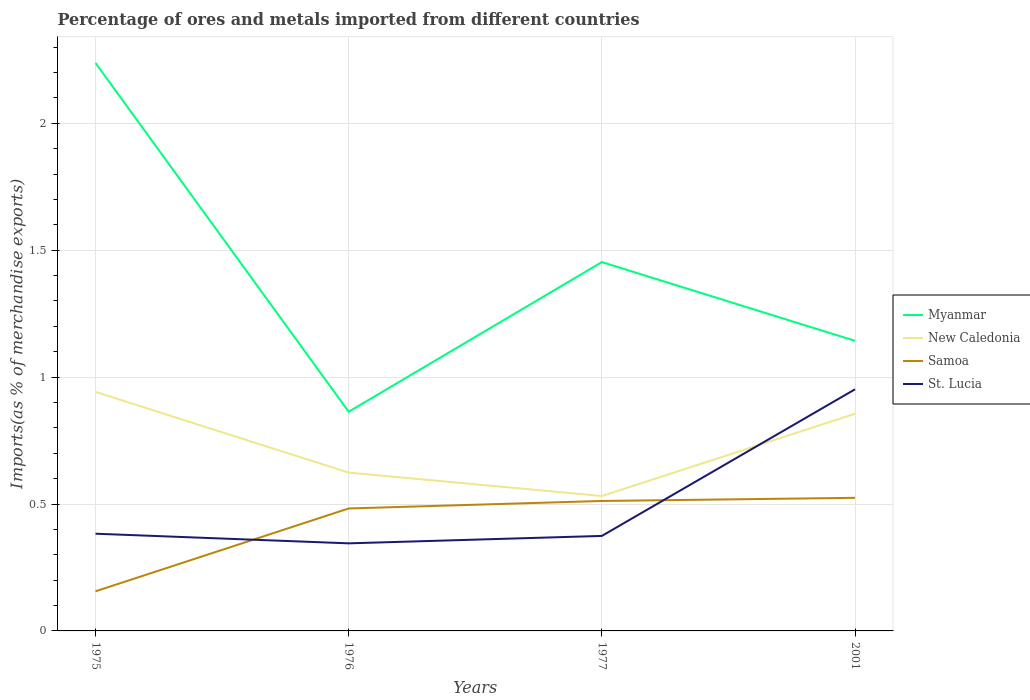Is the number of lines equal to the number of legend labels?
Offer a very short reply. Yes. Across all years, what is the maximum percentage of imports to different countries in New Caledonia?
Ensure brevity in your answer.  0.53. In which year was the percentage of imports to different countries in Samoa maximum?
Give a very brief answer. 1975. What is the total percentage of imports to different countries in Myanmar in the graph?
Your answer should be very brief. 0.78. What is the difference between the highest and the second highest percentage of imports to different countries in Myanmar?
Keep it short and to the point. 1.37. Is the percentage of imports to different countries in New Caledonia strictly greater than the percentage of imports to different countries in Myanmar over the years?
Ensure brevity in your answer.  Yes. Does the graph contain grids?
Give a very brief answer. Yes. Where does the legend appear in the graph?
Offer a very short reply. Center right. How many legend labels are there?
Ensure brevity in your answer.  4. What is the title of the graph?
Your response must be concise. Percentage of ores and metals imported from different countries. Does "Namibia" appear as one of the legend labels in the graph?
Keep it short and to the point. No. What is the label or title of the Y-axis?
Provide a short and direct response. Imports(as % of merchandise exports). What is the Imports(as % of merchandise exports) in Myanmar in 1975?
Offer a terse response. 2.24. What is the Imports(as % of merchandise exports) of New Caledonia in 1975?
Ensure brevity in your answer.  0.94. What is the Imports(as % of merchandise exports) in Samoa in 1975?
Keep it short and to the point. 0.16. What is the Imports(as % of merchandise exports) in St. Lucia in 1975?
Keep it short and to the point. 0.38. What is the Imports(as % of merchandise exports) in Myanmar in 1976?
Give a very brief answer. 0.86. What is the Imports(as % of merchandise exports) in New Caledonia in 1976?
Offer a terse response. 0.62. What is the Imports(as % of merchandise exports) in Samoa in 1976?
Provide a short and direct response. 0.48. What is the Imports(as % of merchandise exports) in St. Lucia in 1976?
Your answer should be very brief. 0.34. What is the Imports(as % of merchandise exports) of Myanmar in 1977?
Give a very brief answer. 1.45. What is the Imports(as % of merchandise exports) in New Caledonia in 1977?
Make the answer very short. 0.53. What is the Imports(as % of merchandise exports) of Samoa in 1977?
Offer a very short reply. 0.51. What is the Imports(as % of merchandise exports) in St. Lucia in 1977?
Your response must be concise. 0.37. What is the Imports(as % of merchandise exports) in Myanmar in 2001?
Your response must be concise. 1.14. What is the Imports(as % of merchandise exports) of New Caledonia in 2001?
Offer a very short reply. 0.86. What is the Imports(as % of merchandise exports) in Samoa in 2001?
Give a very brief answer. 0.52. What is the Imports(as % of merchandise exports) in St. Lucia in 2001?
Make the answer very short. 0.95. Across all years, what is the maximum Imports(as % of merchandise exports) in Myanmar?
Provide a short and direct response. 2.24. Across all years, what is the maximum Imports(as % of merchandise exports) of New Caledonia?
Offer a very short reply. 0.94. Across all years, what is the maximum Imports(as % of merchandise exports) in Samoa?
Offer a very short reply. 0.52. Across all years, what is the maximum Imports(as % of merchandise exports) of St. Lucia?
Provide a succinct answer. 0.95. Across all years, what is the minimum Imports(as % of merchandise exports) of Myanmar?
Your answer should be very brief. 0.86. Across all years, what is the minimum Imports(as % of merchandise exports) in New Caledonia?
Make the answer very short. 0.53. Across all years, what is the minimum Imports(as % of merchandise exports) of Samoa?
Your answer should be very brief. 0.16. Across all years, what is the minimum Imports(as % of merchandise exports) in St. Lucia?
Give a very brief answer. 0.34. What is the total Imports(as % of merchandise exports) in Myanmar in the graph?
Keep it short and to the point. 5.7. What is the total Imports(as % of merchandise exports) in New Caledonia in the graph?
Offer a very short reply. 2.95. What is the total Imports(as % of merchandise exports) in Samoa in the graph?
Give a very brief answer. 1.67. What is the total Imports(as % of merchandise exports) of St. Lucia in the graph?
Your response must be concise. 2.05. What is the difference between the Imports(as % of merchandise exports) in Myanmar in 1975 and that in 1976?
Ensure brevity in your answer.  1.37. What is the difference between the Imports(as % of merchandise exports) of New Caledonia in 1975 and that in 1976?
Provide a short and direct response. 0.32. What is the difference between the Imports(as % of merchandise exports) in Samoa in 1975 and that in 1976?
Your answer should be compact. -0.33. What is the difference between the Imports(as % of merchandise exports) of St. Lucia in 1975 and that in 1976?
Offer a very short reply. 0.04. What is the difference between the Imports(as % of merchandise exports) of Myanmar in 1975 and that in 1977?
Provide a short and direct response. 0.78. What is the difference between the Imports(as % of merchandise exports) in New Caledonia in 1975 and that in 1977?
Your answer should be compact. 0.41. What is the difference between the Imports(as % of merchandise exports) in Samoa in 1975 and that in 1977?
Provide a short and direct response. -0.36. What is the difference between the Imports(as % of merchandise exports) of St. Lucia in 1975 and that in 1977?
Keep it short and to the point. 0.01. What is the difference between the Imports(as % of merchandise exports) in Myanmar in 1975 and that in 2001?
Keep it short and to the point. 1.09. What is the difference between the Imports(as % of merchandise exports) of New Caledonia in 1975 and that in 2001?
Your answer should be compact. 0.09. What is the difference between the Imports(as % of merchandise exports) in Samoa in 1975 and that in 2001?
Ensure brevity in your answer.  -0.37. What is the difference between the Imports(as % of merchandise exports) in St. Lucia in 1975 and that in 2001?
Your answer should be very brief. -0.57. What is the difference between the Imports(as % of merchandise exports) of Myanmar in 1976 and that in 1977?
Offer a very short reply. -0.59. What is the difference between the Imports(as % of merchandise exports) in New Caledonia in 1976 and that in 1977?
Provide a succinct answer. 0.09. What is the difference between the Imports(as % of merchandise exports) in Samoa in 1976 and that in 1977?
Provide a succinct answer. -0.03. What is the difference between the Imports(as % of merchandise exports) in St. Lucia in 1976 and that in 1977?
Provide a succinct answer. -0.03. What is the difference between the Imports(as % of merchandise exports) in Myanmar in 1976 and that in 2001?
Provide a short and direct response. -0.28. What is the difference between the Imports(as % of merchandise exports) of New Caledonia in 1976 and that in 2001?
Your answer should be very brief. -0.23. What is the difference between the Imports(as % of merchandise exports) in Samoa in 1976 and that in 2001?
Your answer should be compact. -0.04. What is the difference between the Imports(as % of merchandise exports) in St. Lucia in 1976 and that in 2001?
Ensure brevity in your answer.  -0.61. What is the difference between the Imports(as % of merchandise exports) of Myanmar in 1977 and that in 2001?
Your answer should be compact. 0.31. What is the difference between the Imports(as % of merchandise exports) of New Caledonia in 1977 and that in 2001?
Provide a succinct answer. -0.32. What is the difference between the Imports(as % of merchandise exports) of Samoa in 1977 and that in 2001?
Your answer should be compact. -0.01. What is the difference between the Imports(as % of merchandise exports) in St. Lucia in 1977 and that in 2001?
Provide a succinct answer. -0.58. What is the difference between the Imports(as % of merchandise exports) in Myanmar in 1975 and the Imports(as % of merchandise exports) in New Caledonia in 1976?
Offer a terse response. 1.61. What is the difference between the Imports(as % of merchandise exports) in Myanmar in 1975 and the Imports(as % of merchandise exports) in Samoa in 1976?
Your answer should be very brief. 1.75. What is the difference between the Imports(as % of merchandise exports) in Myanmar in 1975 and the Imports(as % of merchandise exports) in St. Lucia in 1976?
Ensure brevity in your answer.  1.89. What is the difference between the Imports(as % of merchandise exports) of New Caledonia in 1975 and the Imports(as % of merchandise exports) of Samoa in 1976?
Keep it short and to the point. 0.46. What is the difference between the Imports(as % of merchandise exports) of New Caledonia in 1975 and the Imports(as % of merchandise exports) of St. Lucia in 1976?
Offer a terse response. 0.6. What is the difference between the Imports(as % of merchandise exports) in Samoa in 1975 and the Imports(as % of merchandise exports) in St. Lucia in 1976?
Provide a succinct answer. -0.19. What is the difference between the Imports(as % of merchandise exports) of Myanmar in 1975 and the Imports(as % of merchandise exports) of New Caledonia in 1977?
Provide a succinct answer. 1.71. What is the difference between the Imports(as % of merchandise exports) in Myanmar in 1975 and the Imports(as % of merchandise exports) in Samoa in 1977?
Your answer should be compact. 1.73. What is the difference between the Imports(as % of merchandise exports) in Myanmar in 1975 and the Imports(as % of merchandise exports) in St. Lucia in 1977?
Offer a very short reply. 1.86. What is the difference between the Imports(as % of merchandise exports) in New Caledonia in 1975 and the Imports(as % of merchandise exports) in Samoa in 1977?
Make the answer very short. 0.43. What is the difference between the Imports(as % of merchandise exports) of New Caledonia in 1975 and the Imports(as % of merchandise exports) of St. Lucia in 1977?
Your response must be concise. 0.57. What is the difference between the Imports(as % of merchandise exports) in Samoa in 1975 and the Imports(as % of merchandise exports) in St. Lucia in 1977?
Offer a terse response. -0.22. What is the difference between the Imports(as % of merchandise exports) in Myanmar in 1975 and the Imports(as % of merchandise exports) in New Caledonia in 2001?
Your answer should be very brief. 1.38. What is the difference between the Imports(as % of merchandise exports) in Myanmar in 1975 and the Imports(as % of merchandise exports) in Samoa in 2001?
Offer a very short reply. 1.71. What is the difference between the Imports(as % of merchandise exports) of Myanmar in 1975 and the Imports(as % of merchandise exports) of St. Lucia in 2001?
Keep it short and to the point. 1.29. What is the difference between the Imports(as % of merchandise exports) in New Caledonia in 1975 and the Imports(as % of merchandise exports) in Samoa in 2001?
Ensure brevity in your answer.  0.42. What is the difference between the Imports(as % of merchandise exports) of New Caledonia in 1975 and the Imports(as % of merchandise exports) of St. Lucia in 2001?
Provide a short and direct response. -0.01. What is the difference between the Imports(as % of merchandise exports) in Samoa in 1975 and the Imports(as % of merchandise exports) in St. Lucia in 2001?
Keep it short and to the point. -0.8. What is the difference between the Imports(as % of merchandise exports) in Myanmar in 1976 and the Imports(as % of merchandise exports) in New Caledonia in 1977?
Ensure brevity in your answer.  0.33. What is the difference between the Imports(as % of merchandise exports) in Myanmar in 1976 and the Imports(as % of merchandise exports) in Samoa in 1977?
Ensure brevity in your answer.  0.35. What is the difference between the Imports(as % of merchandise exports) in Myanmar in 1976 and the Imports(as % of merchandise exports) in St. Lucia in 1977?
Give a very brief answer. 0.49. What is the difference between the Imports(as % of merchandise exports) in New Caledonia in 1976 and the Imports(as % of merchandise exports) in Samoa in 1977?
Provide a short and direct response. 0.11. What is the difference between the Imports(as % of merchandise exports) in New Caledonia in 1976 and the Imports(as % of merchandise exports) in St. Lucia in 1977?
Your answer should be very brief. 0.25. What is the difference between the Imports(as % of merchandise exports) of Samoa in 1976 and the Imports(as % of merchandise exports) of St. Lucia in 1977?
Offer a terse response. 0.11. What is the difference between the Imports(as % of merchandise exports) in Myanmar in 1976 and the Imports(as % of merchandise exports) in New Caledonia in 2001?
Your answer should be very brief. 0.01. What is the difference between the Imports(as % of merchandise exports) of Myanmar in 1976 and the Imports(as % of merchandise exports) of Samoa in 2001?
Your answer should be very brief. 0.34. What is the difference between the Imports(as % of merchandise exports) of Myanmar in 1976 and the Imports(as % of merchandise exports) of St. Lucia in 2001?
Your answer should be compact. -0.09. What is the difference between the Imports(as % of merchandise exports) of New Caledonia in 1976 and the Imports(as % of merchandise exports) of Samoa in 2001?
Your answer should be very brief. 0.1. What is the difference between the Imports(as % of merchandise exports) of New Caledonia in 1976 and the Imports(as % of merchandise exports) of St. Lucia in 2001?
Offer a terse response. -0.33. What is the difference between the Imports(as % of merchandise exports) in Samoa in 1976 and the Imports(as % of merchandise exports) in St. Lucia in 2001?
Ensure brevity in your answer.  -0.47. What is the difference between the Imports(as % of merchandise exports) in Myanmar in 1977 and the Imports(as % of merchandise exports) in New Caledonia in 2001?
Make the answer very short. 0.6. What is the difference between the Imports(as % of merchandise exports) in Myanmar in 1977 and the Imports(as % of merchandise exports) in Samoa in 2001?
Your answer should be compact. 0.93. What is the difference between the Imports(as % of merchandise exports) of Myanmar in 1977 and the Imports(as % of merchandise exports) of St. Lucia in 2001?
Offer a very short reply. 0.5. What is the difference between the Imports(as % of merchandise exports) of New Caledonia in 1977 and the Imports(as % of merchandise exports) of Samoa in 2001?
Provide a succinct answer. 0.01. What is the difference between the Imports(as % of merchandise exports) of New Caledonia in 1977 and the Imports(as % of merchandise exports) of St. Lucia in 2001?
Your answer should be compact. -0.42. What is the difference between the Imports(as % of merchandise exports) in Samoa in 1977 and the Imports(as % of merchandise exports) in St. Lucia in 2001?
Keep it short and to the point. -0.44. What is the average Imports(as % of merchandise exports) of Myanmar per year?
Offer a terse response. 1.42. What is the average Imports(as % of merchandise exports) of New Caledonia per year?
Provide a short and direct response. 0.74. What is the average Imports(as % of merchandise exports) in Samoa per year?
Ensure brevity in your answer.  0.42. What is the average Imports(as % of merchandise exports) of St. Lucia per year?
Your answer should be compact. 0.51. In the year 1975, what is the difference between the Imports(as % of merchandise exports) in Myanmar and Imports(as % of merchandise exports) in New Caledonia?
Your answer should be compact. 1.3. In the year 1975, what is the difference between the Imports(as % of merchandise exports) of Myanmar and Imports(as % of merchandise exports) of Samoa?
Keep it short and to the point. 2.08. In the year 1975, what is the difference between the Imports(as % of merchandise exports) of Myanmar and Imports(as % of merchandise exports) of St. Lucia?
Your answer should be very brief. 1.85. In the year 1975, what is the difference between the Imports(as % of merchandise exports) of New Caledonia and Imports(as % of merchandise exports) of Samoa?
Your answer should be very brief. 0.79. In the year 1975, what is the difference between the Imports(as % of merchandise exports) of New Caledonia and Imports(as % of merchandise exports) of St. Lucia?
Your answer should be very brief. 0.56. In the year 1975, what is the difference between the Imports(as % of merchandise exports) of Samoa and Imports(as % of merchandise exports) of St. Lucia?
Give a very brief answer. -0.23. In the year 1976, what is the difference between the Imports(as % of merchandise exports) in Myanmar and Imports(as % of merchandise exports) in New Caledonia?
Offer a terse response. 0.24. In the year 1976, what is the difference between the Imports(as % of merchandise exports) in Myanmar and Imports(as % of merchandise exports) in Samoa?
Offer a terse response. 0.38. In the year 1976, what is the difference between the Imports(as % of merchandise exports) in Myanmar and Imports(as % of merchandise exports) in St. Lucia?
Your answer should be very brief. 0.52. In the year 1976, what is the difference between the Imports(as % of merchandise exports) of New Caledonia and Imports(as % of merchandise exports) of Samoa?
Provide a short and direct response. 0.14. In the year 1976, what is the difference between the Imports(as % of merchandise exports) of New Caledonia and Imports(as % of merchandise exports) of St. Lucia?
Make the answer very short. 0.28. In the year 1976, what is the difference between the Imports(as % of merchandise exports) in Samoa and Imports(as % of merchandise exports) in St. Lucia?
Offer a very short reply. 0.14. In the year 1977, what is the difference between the Imports(as % of merchandise exports) in Myanmar and Imports(as % of merchandise exports) in New Caledonia?
Give a very brief answer. 0.92. In the year 1977, what is the difference between the Imports(as % of merchandise exports) of Myanmar and Imports(as % of merchandise exports) of Samoa?
Your response must be concise. 0.94. In the year 1977, what is the difference between the Imports(as % of merchandise exports) of Myanmar and Imports(as % of merchandise exports) of St. Lucia?
Make the answer very short. 1.08. In the year 1977, what is the difference between the Imports(as % of merchandise exports) of New Caledonia and Imports(as % of merchandise exports) of Samoa?
Your answer should be very brief. 0.02. In the year 1977, what is the difference between the Imports(as % of merchandise exports) in New Caledonia and Imports(as % of merchandise exports) in St. Lucia?
Offer a very short reply. 0.16. In the year 1977, what is the difference between the Imports(as % of merchandise exports) of Samoa and Imports(as % of merchandise exports) of St. Lucia?
Your response must be concise. 0.14. In the year 2001, what is the difference between the Imports(as % of merchandise exports) of Myanmar and Imports(as % of merchandise exports) of New Caledonia?
Your answer should be very brief. 0.29. In the year 2001, what is the difference between the Imports(as % of merchandise exports) in Myanmar and Imports(as % of merchandise exports) in Samoa?
Ensure brevity in your answer.  0.62. In the year 2001, what is the difference between the Imports(as % of merchandise exports) in Myanmar and Imports(as % of merchandise exports) in St. Lucia?
Offer a terse response. 0.19. In the year 2001, what is the difference between the Imports(as % of merchandise exports) of New Caledonia and Imports(as % of merchandise exports) of Samoa?
Provide a short and direct response. 0.33. In the year 2001, what is the difference between the Imports(as % of merchandise exports) in New Caledonia and Imports(as % of merchandise exports) in St. Lucia?
Your answer should be very brief. -0.1. In the year 2001, what is the difference between the Imports(as % of merchandise exports) in Samoa and Imports(as % of merchandise exports) in St. Lucia?
Your response must be concise. -0.43. What is the ratio of the Imports(as % of merchandise exports) in Myanmar in 1975 to that in 1976?
Ensure brevity in your answer.  2.59. What is the ratio of the Imports(as % of merchandise exports) in New Caledonia in 1975 to that in 1976?
Provide a short and direct response. 1.51. What is the ratio of the Imports(as % of merchandise exports) in Samoa in 1975 to that in 1976?
Your answer should be very brief. 0.32. What is the ratio of the Imports(as % of merchandise exports) of St. Lucia in 1975 to that in 1976?
Keep it short and to the point. 1.11. What is the ratio of the Imports(as % of merchandise exports) of Myanmar in 1975 to that in 1977?
Provide a succinct answer. 1.54. What is the ratio of the Imports(as % of merchandise exports) of New Caledonia in 1975 to that in 1977?
Offer a terse response. 1.77. What is the ratio of the Imports(as % of merchandise exports) of Samoa in 1975 to that in 1977?
Keep it short and to the point. 0.3. What is the ratio of the Imports(as % of merchandise exports) in St. Lucia in 1975 to that in 1977?
Keep it short and to the point. 1.02. What is the ratio of the Imports(as % of merchandise exports) in Myanmar in 1975 to that in 2001?
Ensure brevity in your answer.  1.96. What is the ratio of the Imports(as % of merchandise exports) in New Caledonia in 1975 to that in 2001?
Provide a short and direct response. 1.1. What is the ratio of the Imports(as % of merchandise exports) of Samoa in 1975 to that in 2001?
Give a very brief answer. 0.3. What is the ratio of the Imports(as % of merchandise exports) of St. Lucia in 1975 to that in 2001?
Your response must be concise. 0.4. What is the ratio of the Imports(as % of merchandise exports) in Myanmar in 1976 to that in 1977?
Your answer should be compact. 0.59. What is the ratio of the Imports(as % of merchandise exports) in New Caledonia in 1976 to that in 1977?
Your answer should be very brief. 1.17. What is the ratio of the Imports(as % of merchandise exports) in Samoa in 1976 to that in 1977?
Make the answer very short. 0.94. What is the ratio of the Imports(as % of merchandise exports) of St. Lucia in 1976 to that in 1977?
Your response must be concise. 0.92. What is the ratio of the Imports(as % of merchandise exports) in Myanmar in 1976 to that in 2001?
Give a very brief answer. 0.76. What is the ratio of the Imports(as % of merchandise exports) of New Caledonia in 1976 to that in 2001?
Give a very brief answer. 0.73. What is the ratio of the Imports(as % of merchandise exports) of Samoa in 1976 to that in 2001?
Make the answer very short. 0.92. What is the ratio of the Imports(as % of merchandise exports) in St. Lucia in 1976 to that in 2001?
Your response must be concise. 0.36. What is the ratio of the Imports(as % of merchandise exports) of Myanmar in 1977 to that in 2001?
Give a very brief answer. 1.27. What is the ratio of the Imports(as % of merchandise exports) in New Caledonia in 1977 to that in 2001?
Keep it short and to the point. 0.62. What is the ratio of the Imports(as % of merchandise exports) in Samoa in 1977 to that in 2001?
Your response must be concise. 0.98. What is the ratio of the Imports(as % of merchandise exports) in St. Lucia in 1977 to that in 2001?
Ensure brevity in your answer.  0.39. What is the difference between the highest and the second highest Imports(as % of merchandise exports) in Myanmar?
Provide a short and direct response. 0.78. What is the difference between the highest and the second highest Imports(as % of merchandise exports) of New Caledonia?
Your answer should be compact. 0.09. What is the difference between the highest and the second highest Imports(as % of merchandise exports) in Samoa?
Offer a very short reply. 0.01. What is the difference between the highest and the second highest Imports(as % of merchandise exports) in St. Lucia?
Keep it short and to the point. 0.57. What is the difference between the highest and the lowest Imports(as % of merchandise exports) of Myanmar?
Ensure brevity in your answer.  1.37. What is the difference between the highest and the lowest Imports(as % of merchandise exports) in New Caledonia?
Offer a terse response. 0.41. What is the difference between the highest and the lowest Imports(as % of merchandise exports) in Samoa?
Give a very brief answer. 0.37. What is the difference between the highest and the lowest Imports(as % of merchandise exports) of St. Lucia?
Provide a short and direct response. 0.61. 